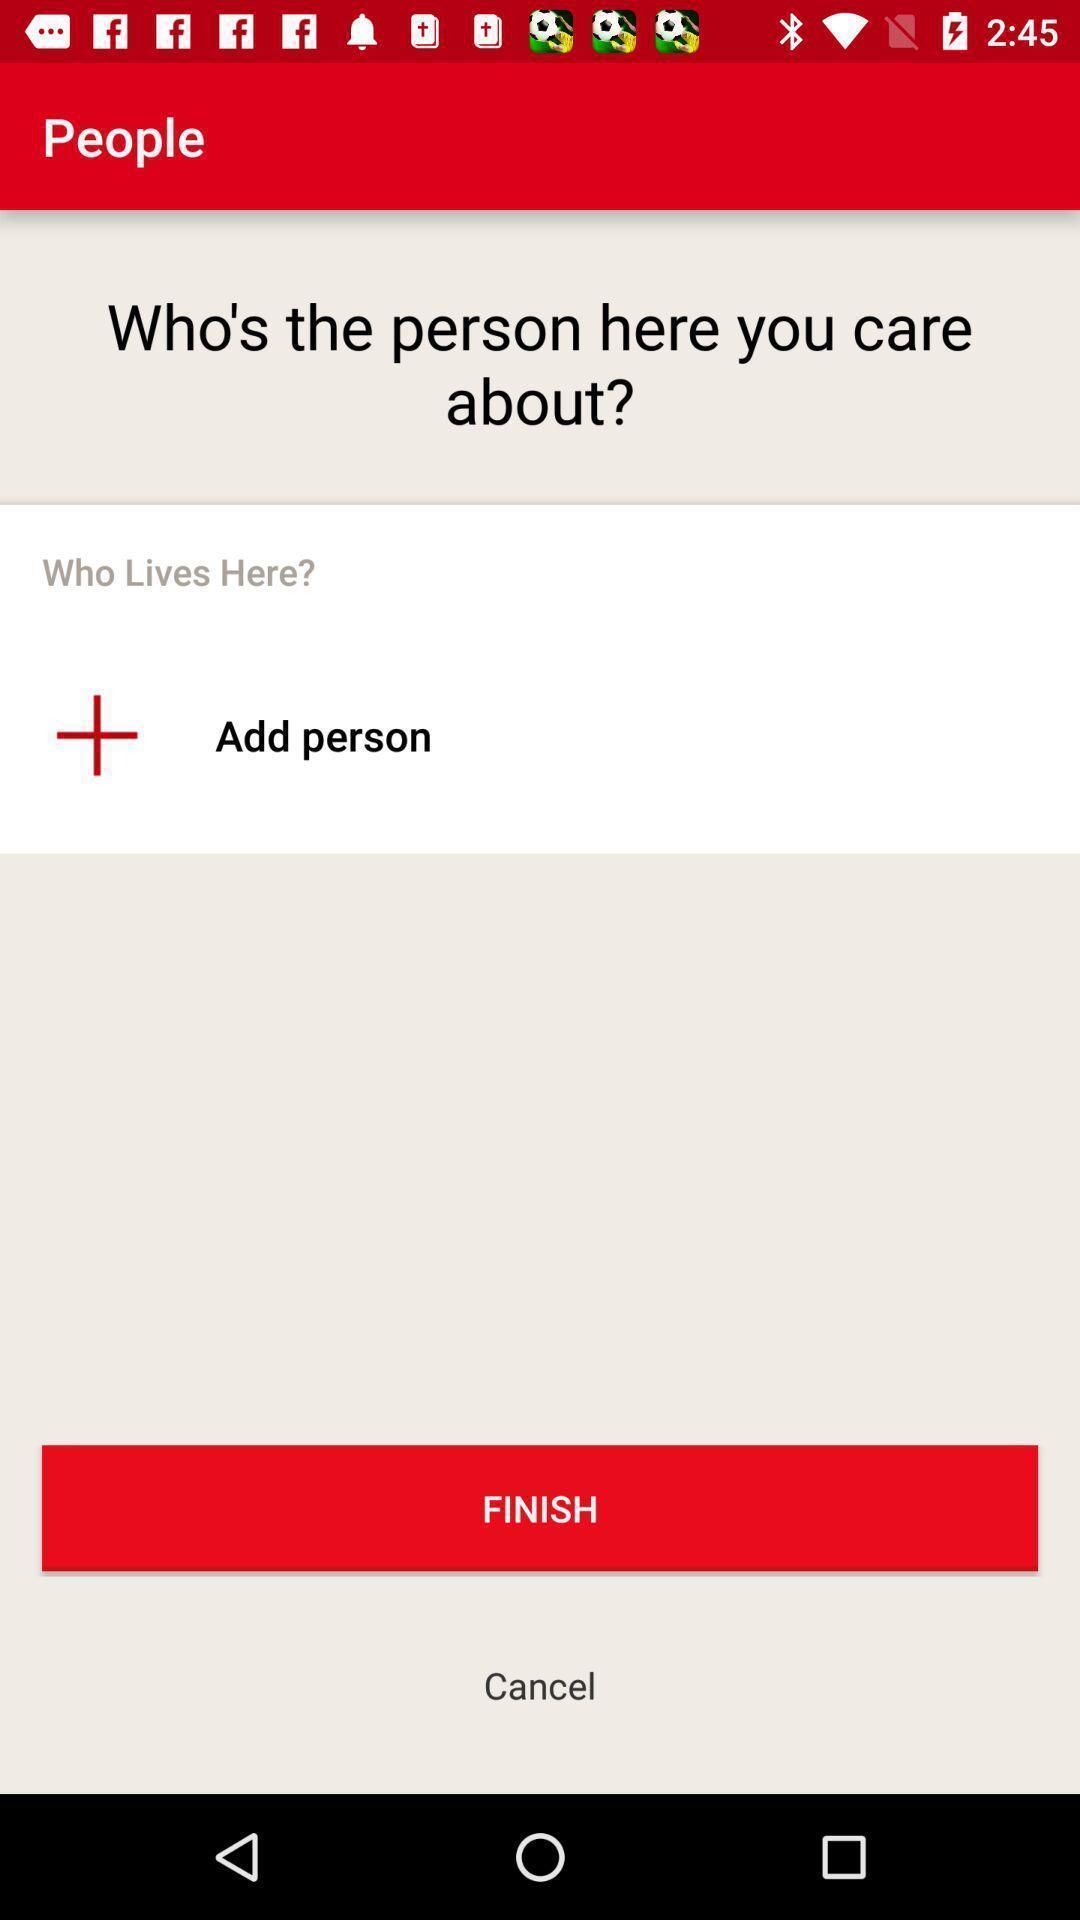Describe the content in this image. Screen showing the add people in social app. 